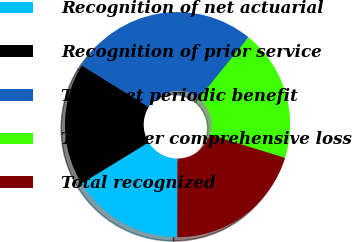<chart> <loc_0><loc_0><loc_500><loc_500><pie_chart><fcel>Recognition of net actuarial<fcel>Recognition of prior service<fcel>Total net periodic benefit<fcel>Total other comprehensive loss<fcel>Total recognized<nl><fcel>16.22%<fcel>17.57%<fcel>27.03%<fcel>18.92%<fcel>20.27%<nl></chart> 